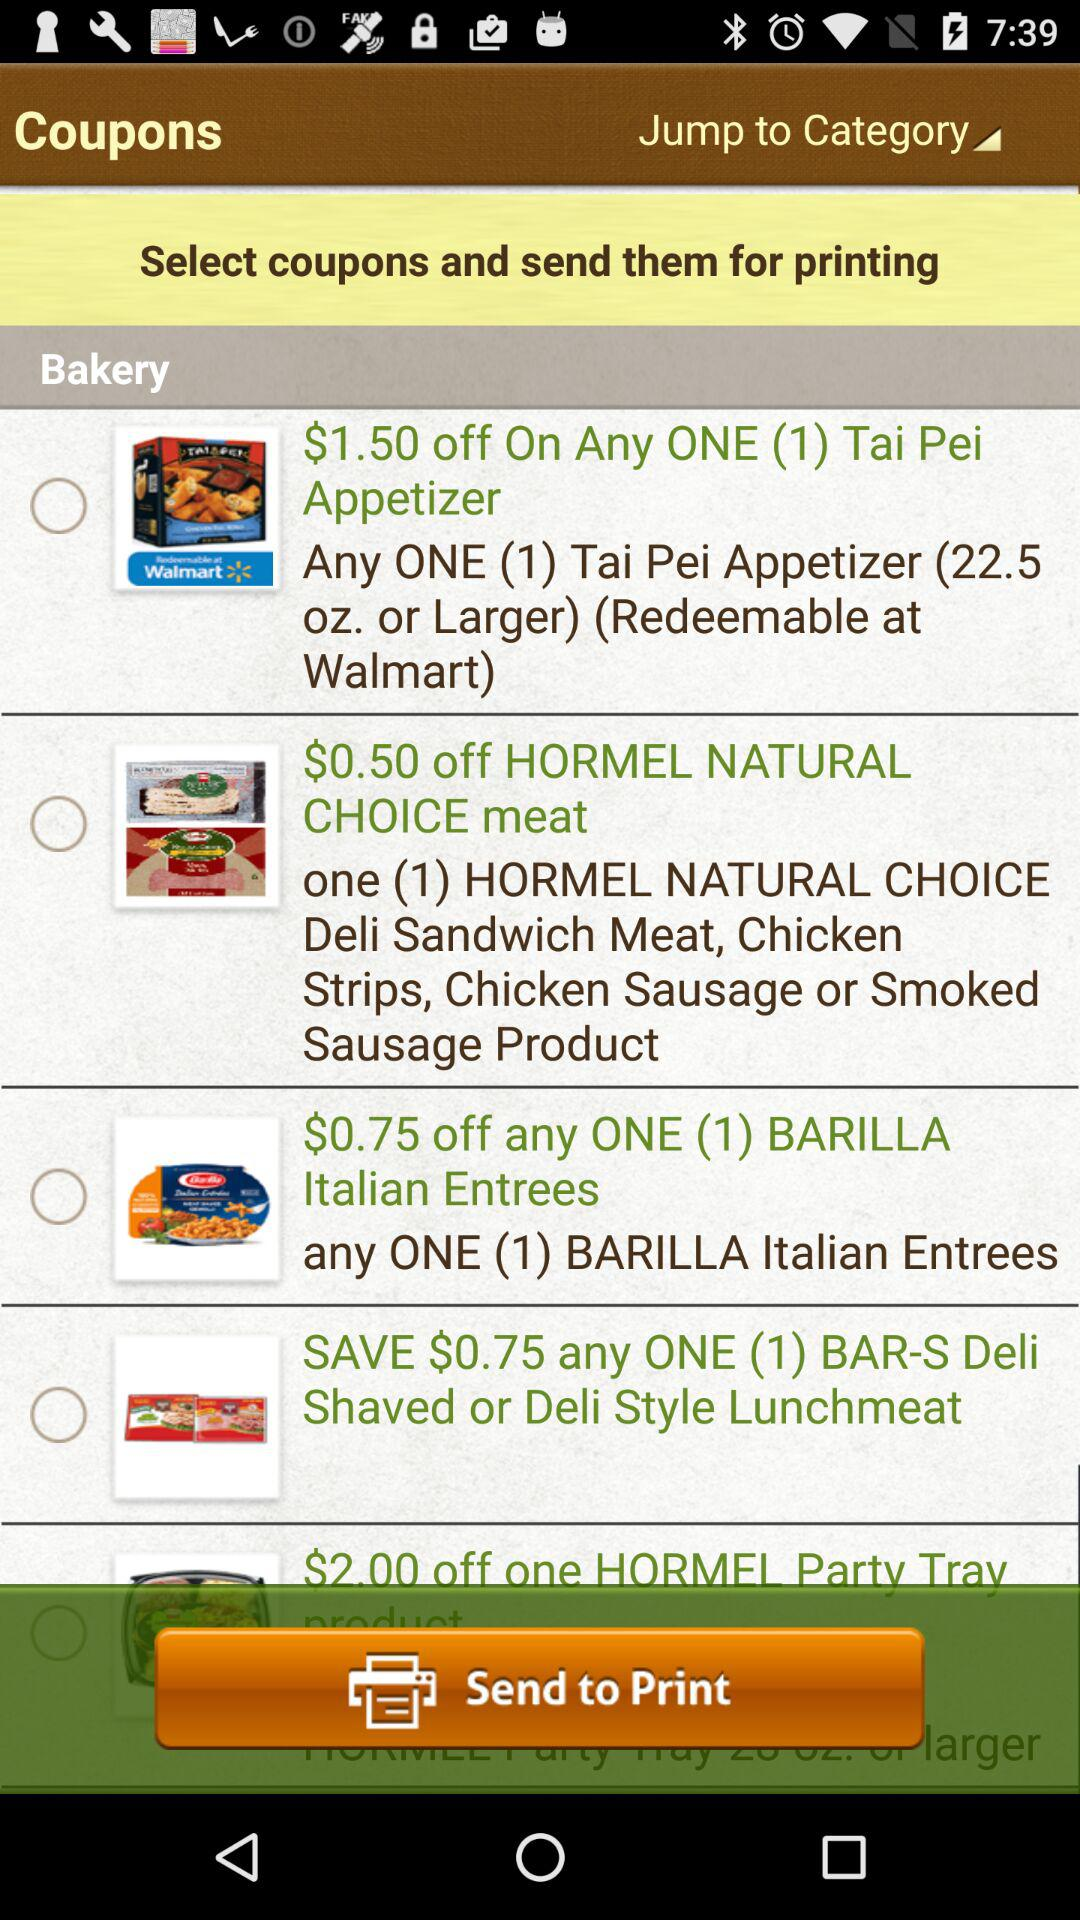On what items are the coupons applicable? The coupons are applicable on "Tai Pei Appetizer", "HORMEL NATURAL CHOICE meat", "BARILLA Italian Entrees" and "BAR-S Deli Shaved or Deli Style Lunchmeat". 